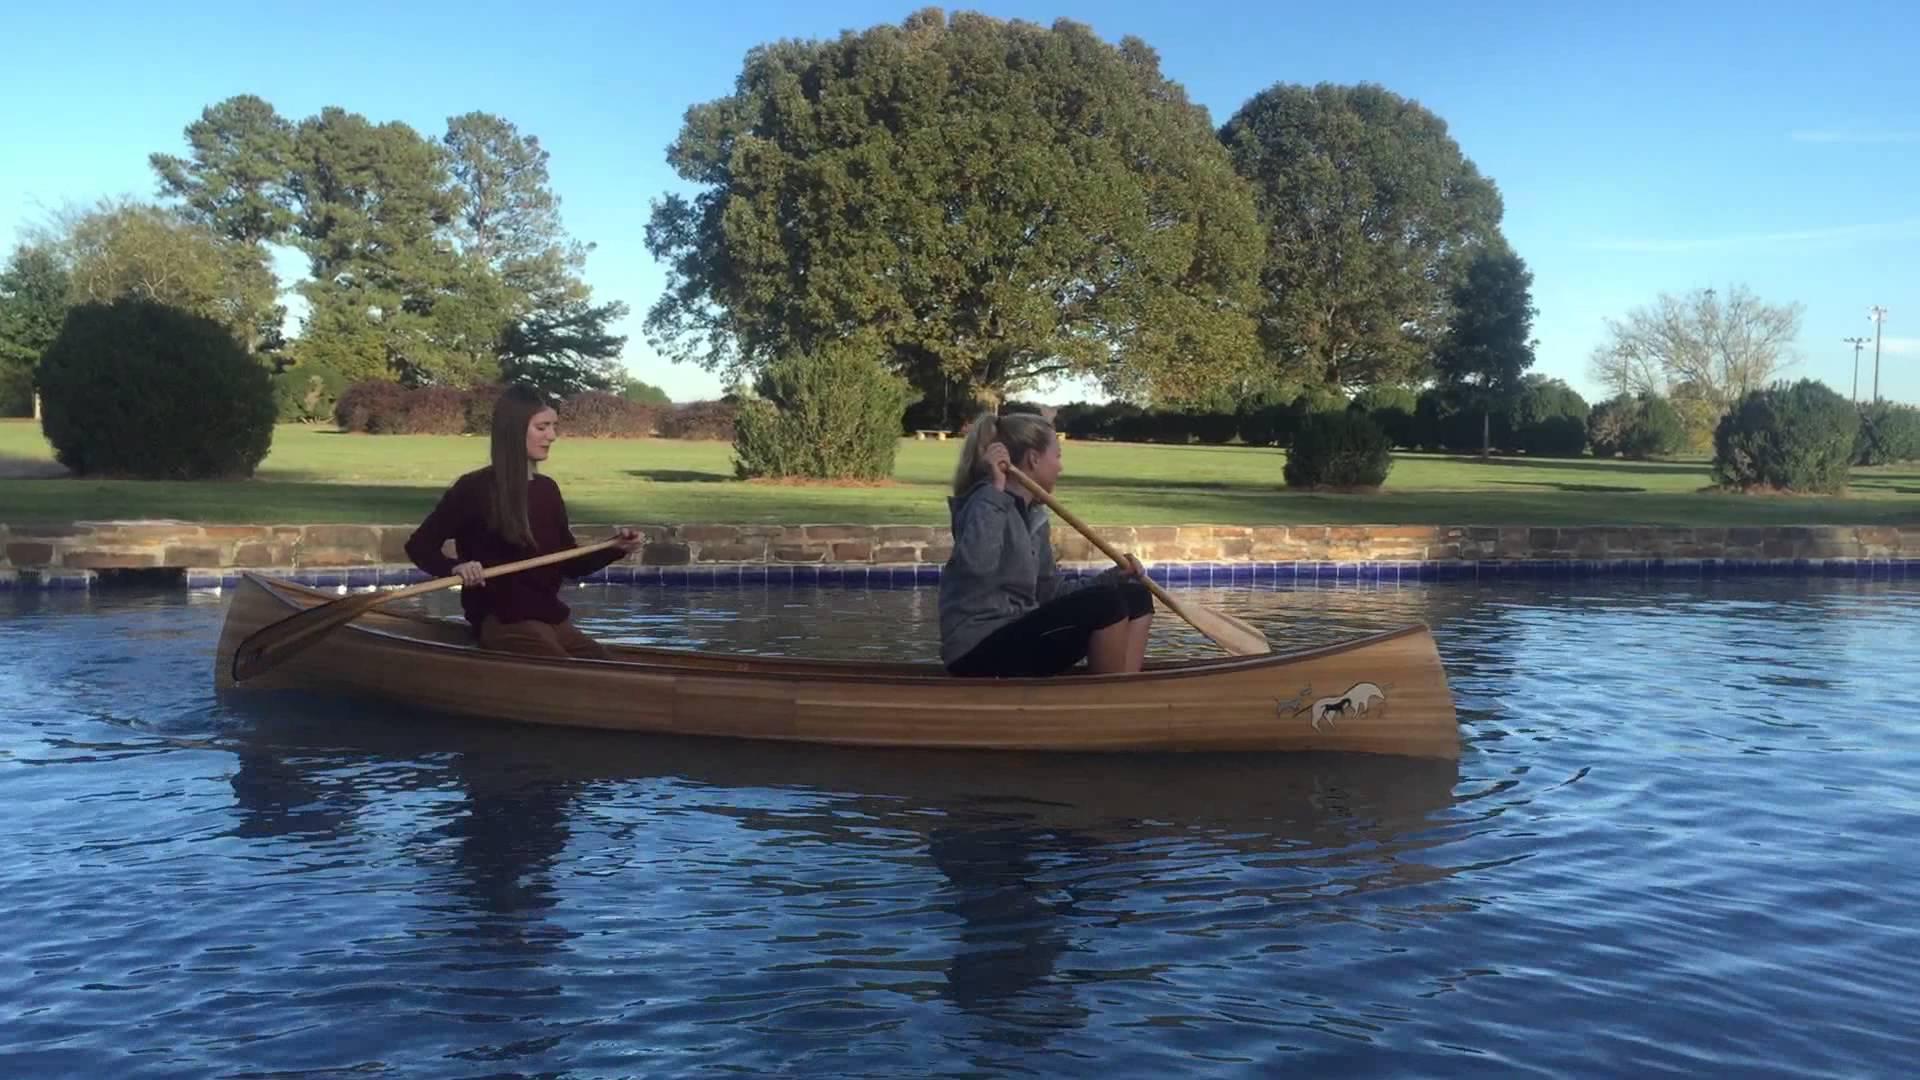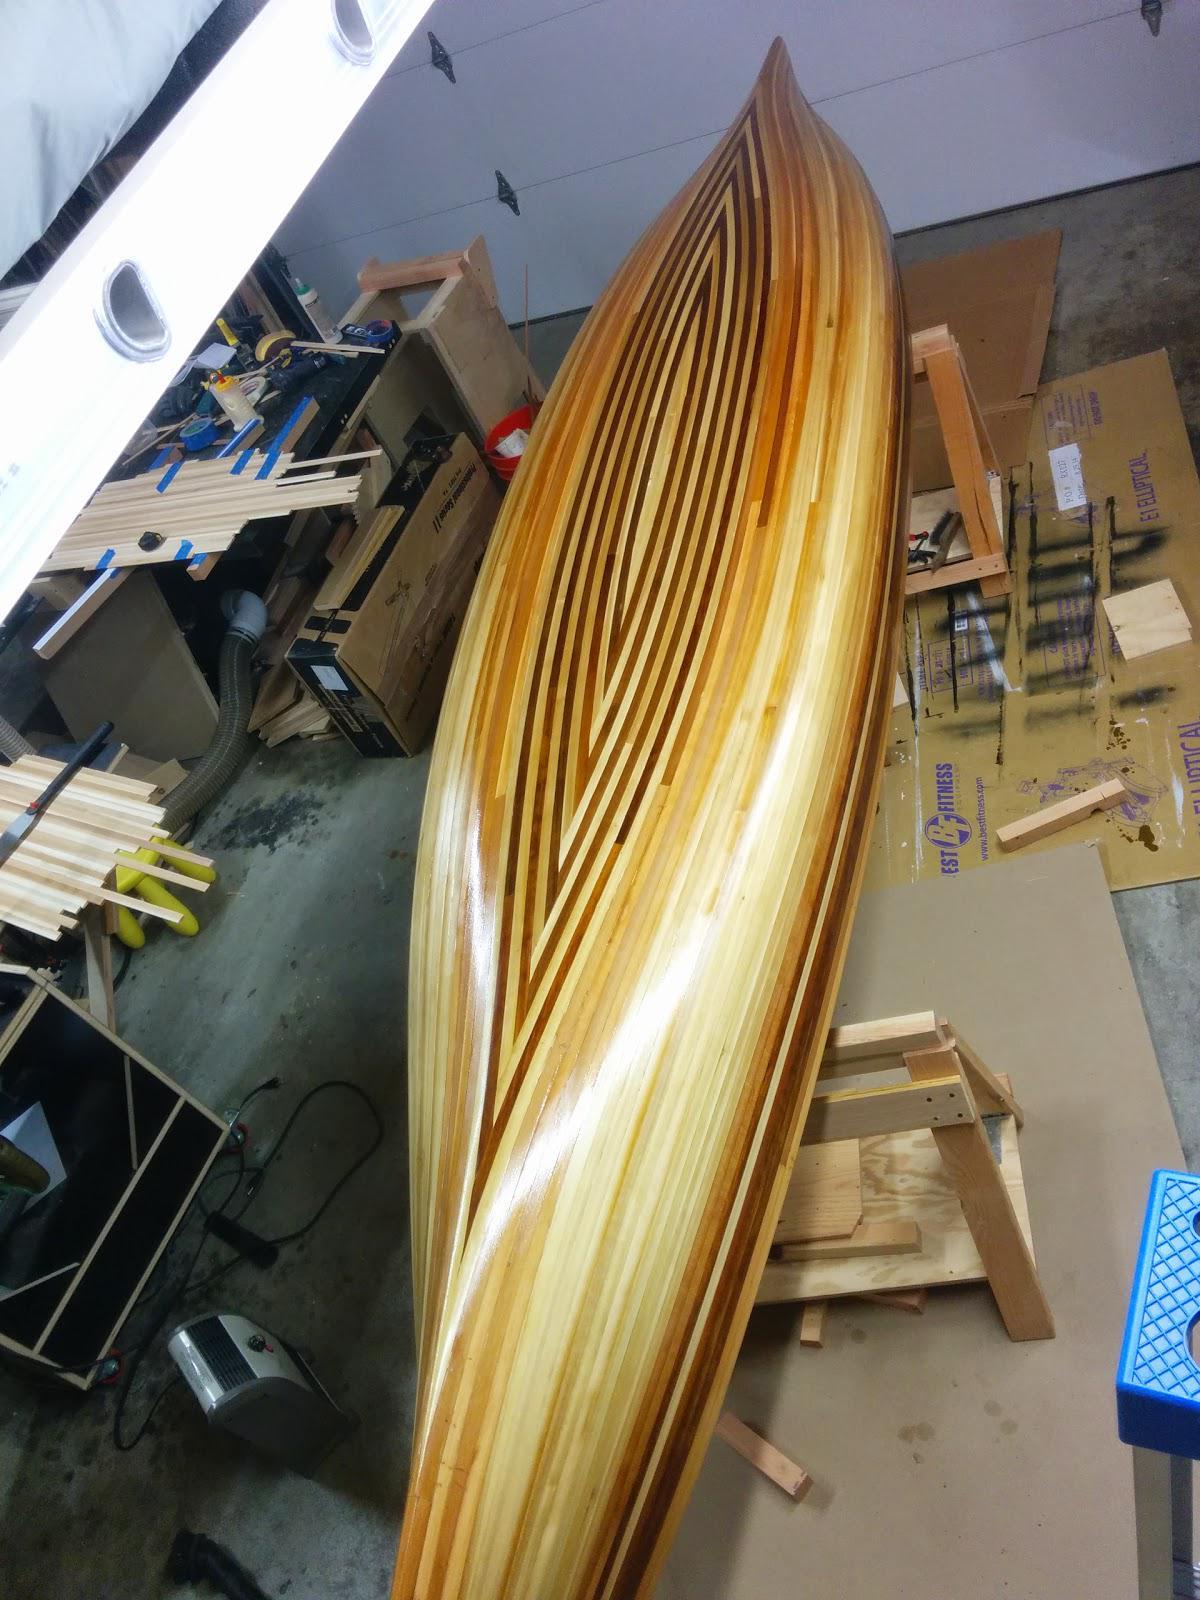The first image is the image on the left, the second image is the image on the right. Analyze the images presented: Is the assertion "One canoe is near water." valid? Answer yes or no. Yes. The first image is the image on the left, the second image is the image on the right. Given the left and right images, does the statement "Two boats sit on the land in the image on the right." hold true? Answer yes or no. No. 